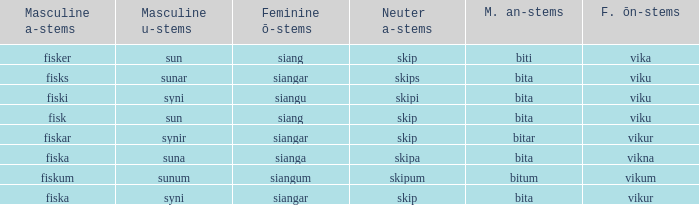What ending does siangu get for ön? Viku. 